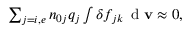<formula> <loc_0><loc_0><loc_500><loc_500>\begin{array} { r } { \sum _ { j = i , e } n _ { 0 j } q _ { j } \int \delta f _ { j { k } } \, d v \approx 0 , } \end{array}</formula> 